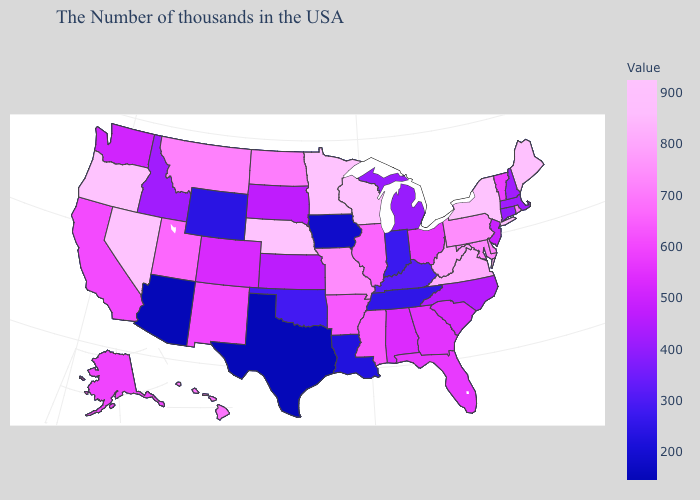Does Montana have the highest value in the West?
Answer briefly. No. Among the states that border Maryland , does Pennsylvania have the highest value?
Keep it brief. No. Does North Carolina have a lower value than Missouri?
Keep it brief. Yes. Which states have the lowest value in the West?
Short answer required. Arizona. 